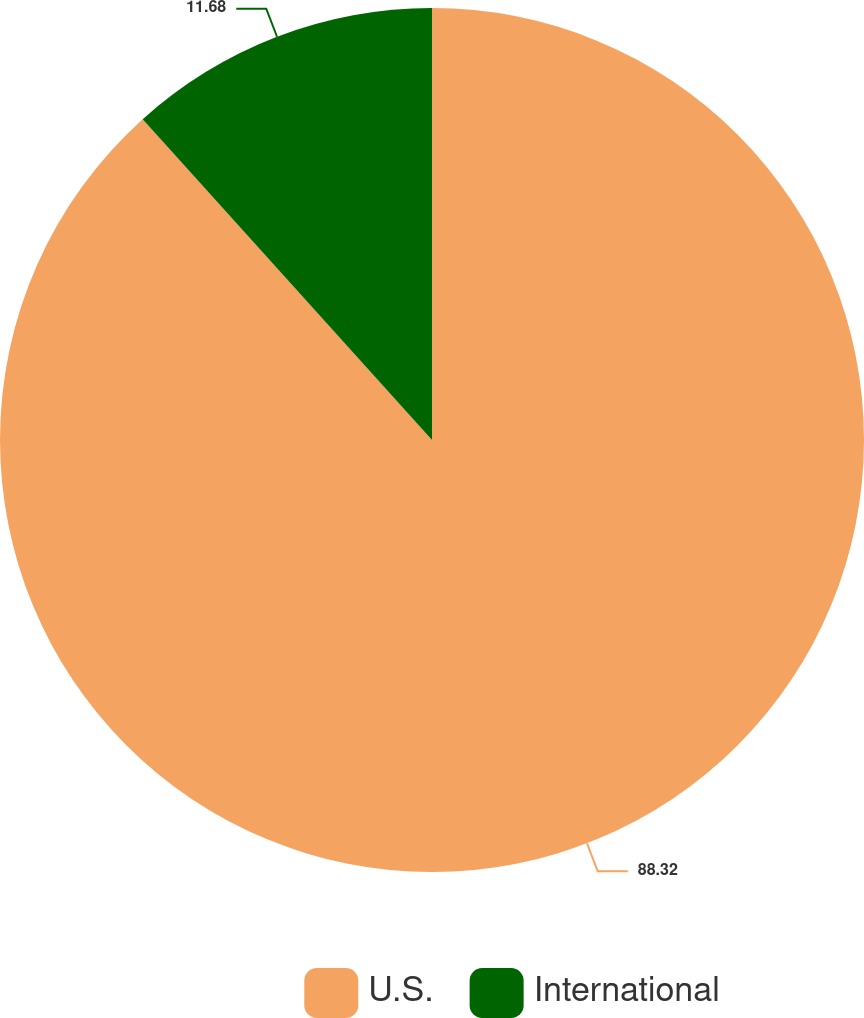<chart> <loc_0><loc_0><loc_500><loc_500><pie_chart><fcel>U.S.<fcel>International<nl><fcel>88.32%<fcel>11.68%<nl></chart> 